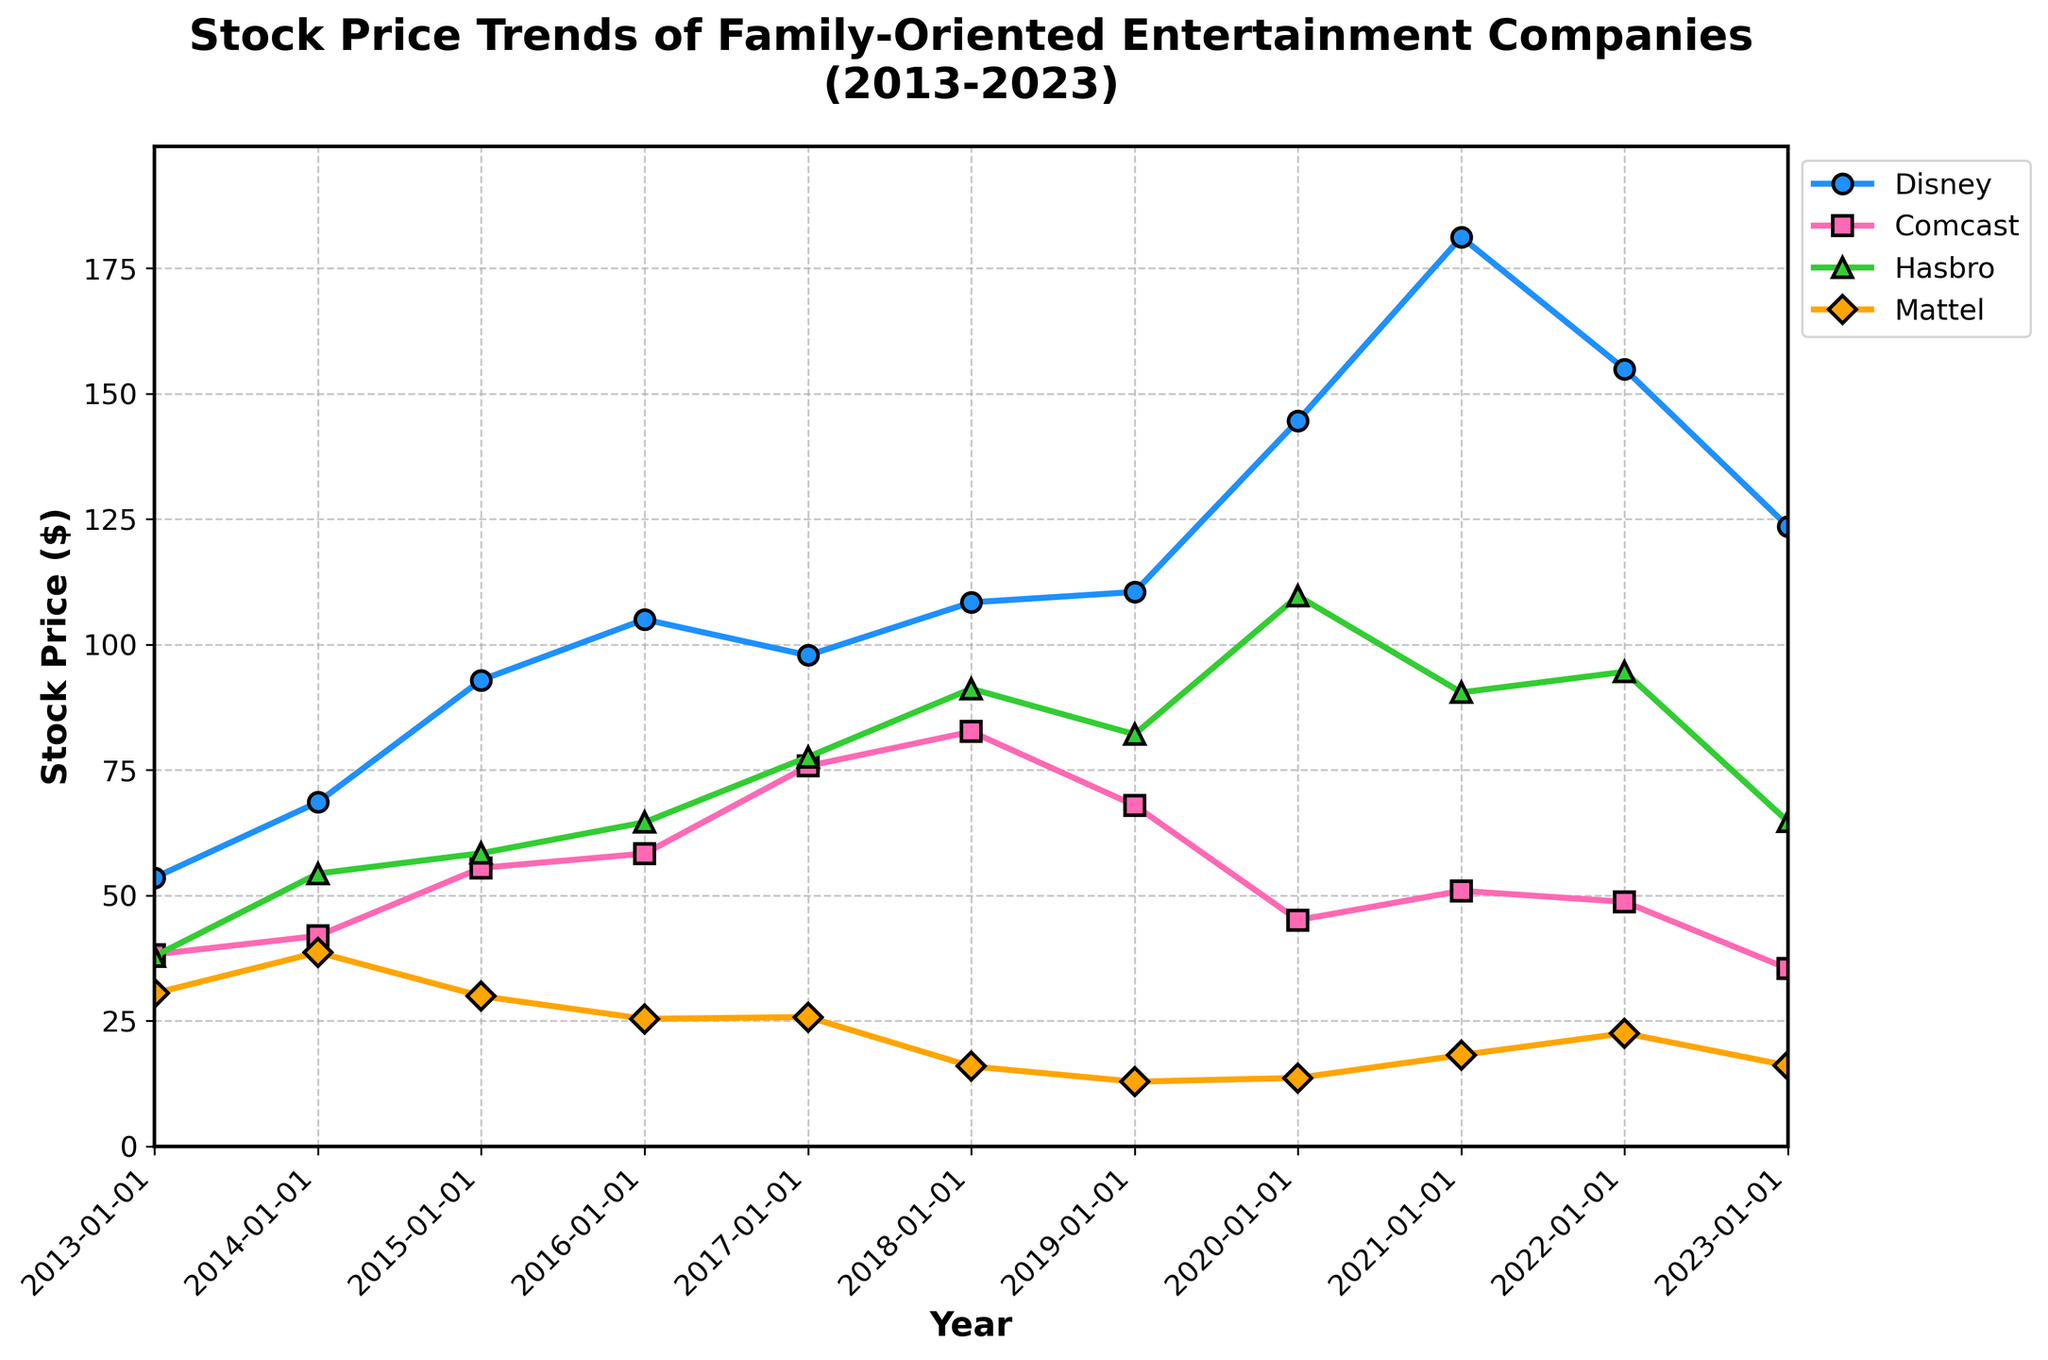Which company had the highest stock price in 2021? Look at the data points for 2021 and identify the company with the highest stock price.
Answer: Disney What is the general trend of Mattel's stock price from 2013 to 2023? Observe Mattel's stock price over the years. It decreases significantly from 2013 to 2019, remains relatively stable with slight increases in 2020 and 2021, then fluctuates slightly towards the end of the period.
Answer: Decreasing, then fluctuating Which company's stock price peaked in 2020? Check the data points for each company in 2020 and see which one had its highest value relative to other years.
Answer: Disney What are the average stock prices for Hasbro over the decade 2013-2023? Sum up Hasbro's stock prices from 2013 to 2023 and then divide by the number of years (11). [(37.9 + 54.36 + 58.42 + 64.58 + 77.59 + 91.19 + 82.12 + 109.68 + 90.46 + 94.57 + 64.72) / 11]
Answer: 75.82 In which year did Comcast's stock price reach its maximum value? Scan the data to find the year when Comcast had its highest stock price.
Answer: 2018 How did Disney's stock price change from 2019 to 2023? Compare Disney's stock prices at the start of 2019 and the start of 2023, noting the difference. (144.63 in 2020 minus 123.52 in 2023)
Answer: Decreased Compare Mattel's stock price in 2018 to 2023. By what percentage did it change? Calculate the percentage change from 2018 to 2023 using the formula [(New Value - Old Value) / Old Value] * 100. [(16.09 - 15.95) / 15.95] * 100
Answer: ≈ 0.88% Is there any year when all companies saw a rise in their stock prices compared to the previous year? Check each year and see if all companies had an increase compared to the immediately previous year.
Answer: No Which company showed the most stable stock price trend over the decade? Comparing the fluctuations for each company's stock prices visually, identify the company with the least volatility.
Answer: Comcast 